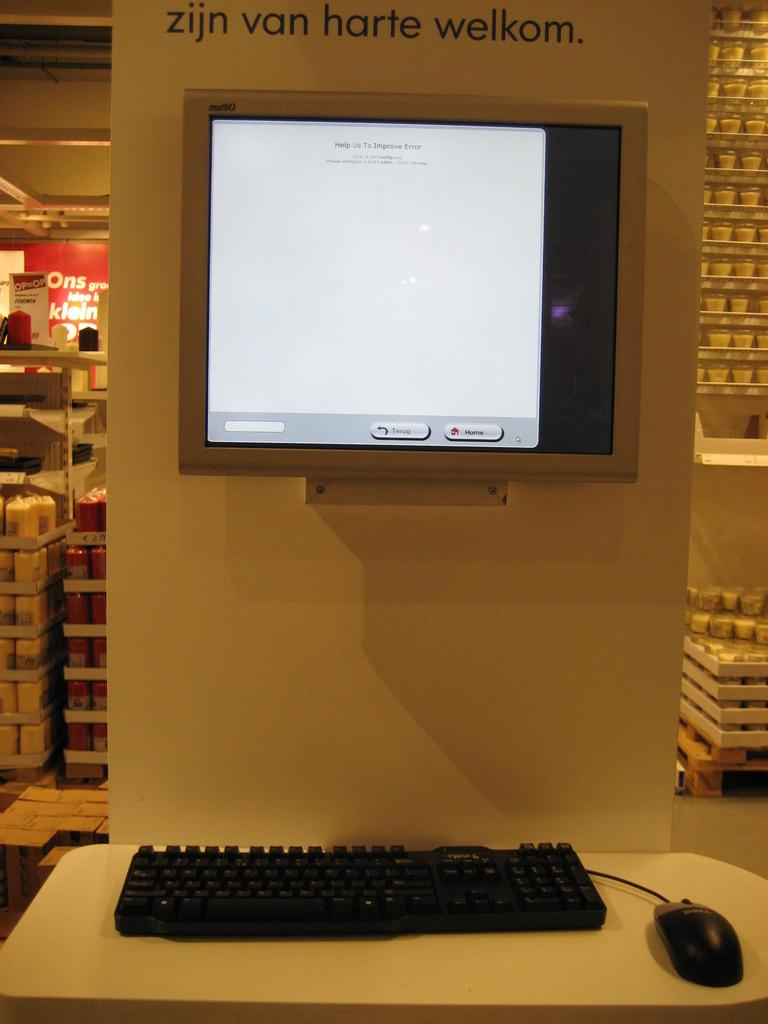<image>
Summarize the visual content of the image. A computer screen on a wall in a store that says Help Us To Improve Error on the screen. 